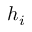<formula> <loc_0><loc_0><loc_500><loc_500>h _ { i }</formula> 